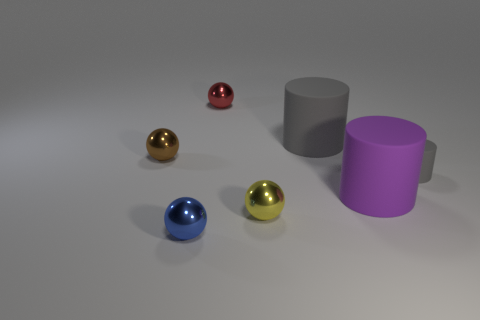What number of balls are behind the large thing that is behind the tiny cylinder?
Your answer should be compact. 1. There is a large cylinder that is the same color as the small matte cylinder; what material is it?
Your answer should be compact. Rubber. What number of other things are the same color as the small matte thing?
Give a very brief answer. 1. There is a tiny metal sphere on the left side of the ball that is in front of the small yellow sphere; what is its color?
Ensure brevity in your answer.  Brown. Is there a big matte thing of the same color as the small rubber cylinder?
Provide a short and direct response. Yes. What number of metallic things are red balls or small blue things?
Your response must be concise. 2. Are there any tiny red spheres made of the same material as the big purple cylinder?
Ensure brevity in your answer.  No. How many things are both to the right of the tiny red sphere and in front of the brown object?
Your answer should be very brief. 3. Are there fewer gray matte cylinders to the left of the brown shiny object than yellow balls in front of the big purple thing?
Your answer should be very brief. Yes. Do the purple object and the brown object have the same shape?
Offer a terse response. No. 